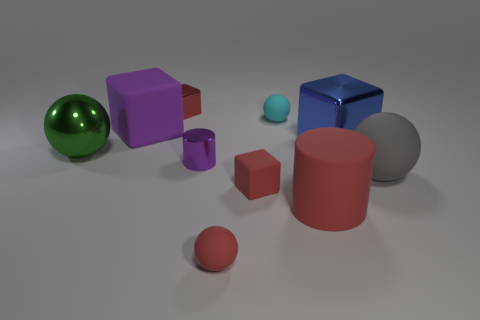Are there any big cyan metallic balls?
Give a very brief answer. No. What is the shape of the thing that is behind the big gray matte ball and in front of the green thing?
Keep it short and to the point. Cylinder. There is a shiny thing in front of the green thing; what size is it?
Make the answer very short. Small. There is a large rubber thing behind the blue shiny cube; is its color the same as the large rubber cylinder?
Your answer should be very brief. No. How many large gray objects are the same shape as the tiny cyan matte thing?
Your answer should be very brief. 1. How many things are tiny rubber balls in front of the tiny cyan matte sphere or metallic objects on the left side of the large blue metallic object?
Keep it short and to the point. 4. How many brown things are either small blocks or large matte blocks?
Offer a very short reply. 0. There is a tiny red thing that is behind the big cylinder and in front of the red metallic cube; what is its material?
Provide a succinct answer. Rubber. Is the material of the tiny cyan sphere the same as the big gray ball?
Your answer should be very brief. Yes. What number of cyan matte spheres are the same size as the blue object?
Keep it short and to the point. 0. 